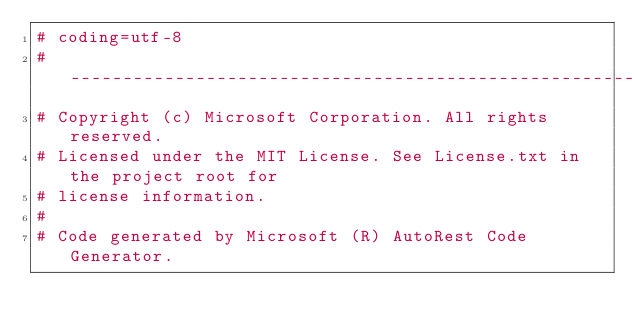Convert code to text. <code><loc_0><loc_0><loc_500><loc_500><_Python_># coding=utf-8
# --------------------------------------------------------------------------
# Copyright (c) Microsoft Corporation. All rights reserved.
# Licensed under the MIT License. See License.txt in the project root for
# license information.
#
# Code generated by Microsoft (R) AutoRest Code Generator.</code> 